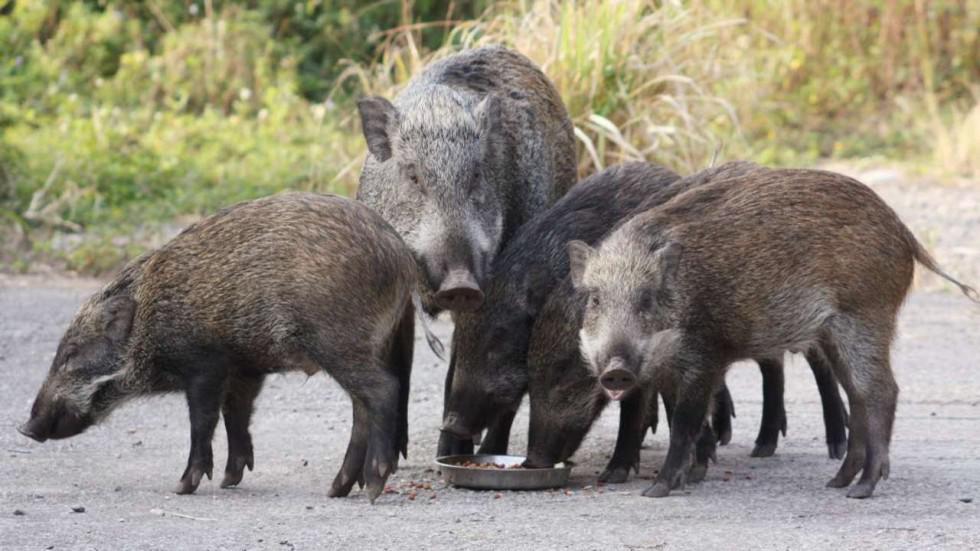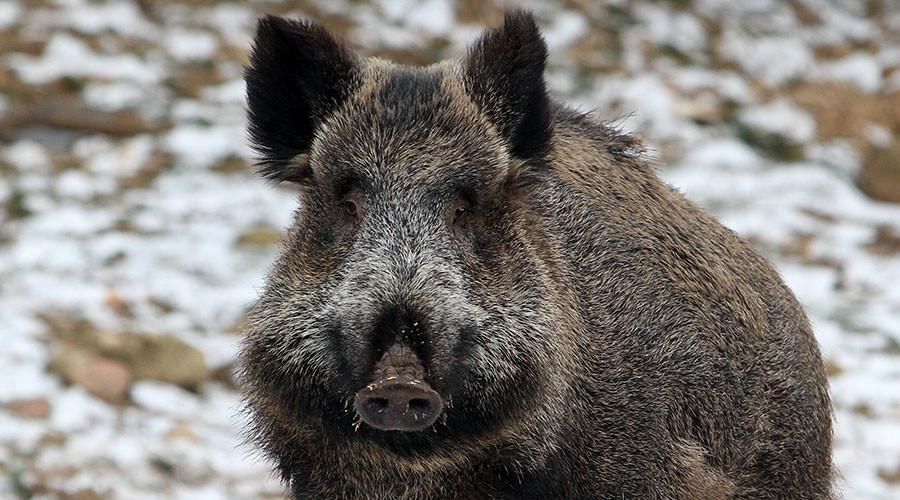The first image is the image on the left, the second image is the image on the right. Given the left and right images, does the statement "The image on the left shows a single warthog." hold true? Answer yes or no. No. The first image is the image on the left, the second image is the image on the right. For the images displayed, is the sentence "The left image contains at least three times as many wild pigs as the right image." factually correct? Answer yes or no. Yes. 